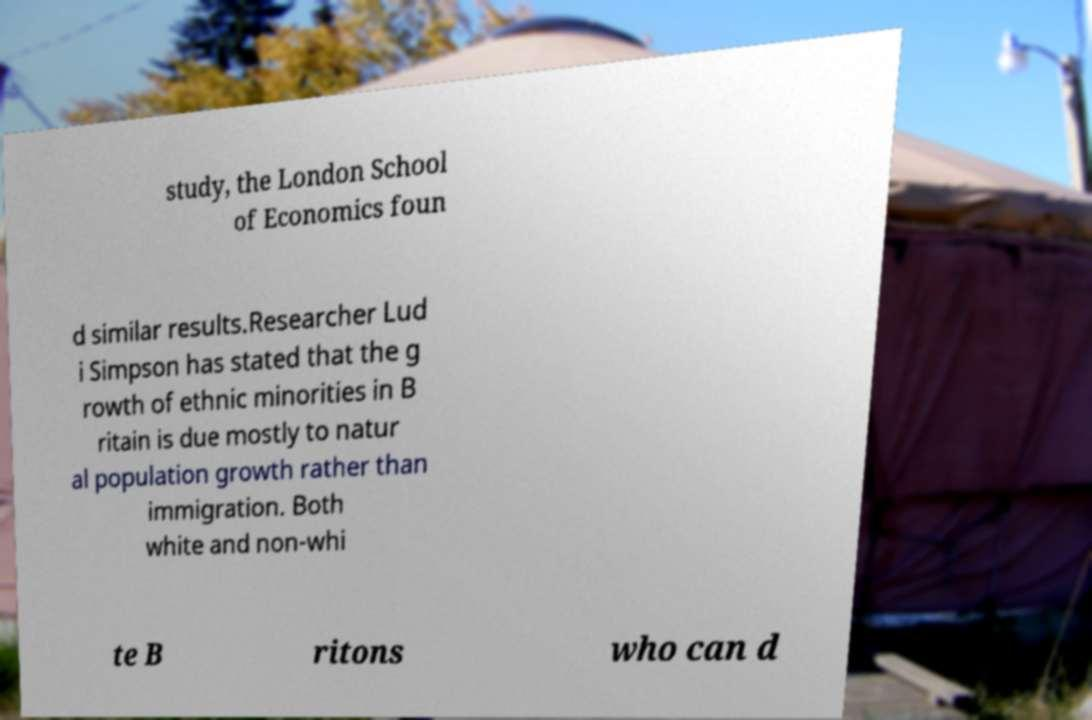Please identify and transcribe the text found in this image. study, the London School of Economics foun d similar results.Researcher Lud i Simpson has stated that the g rowth of ethnic minorities in B ritain is due mostly to natur al population growth rather than immigration. Both white and non-whi te B ritons who can d 